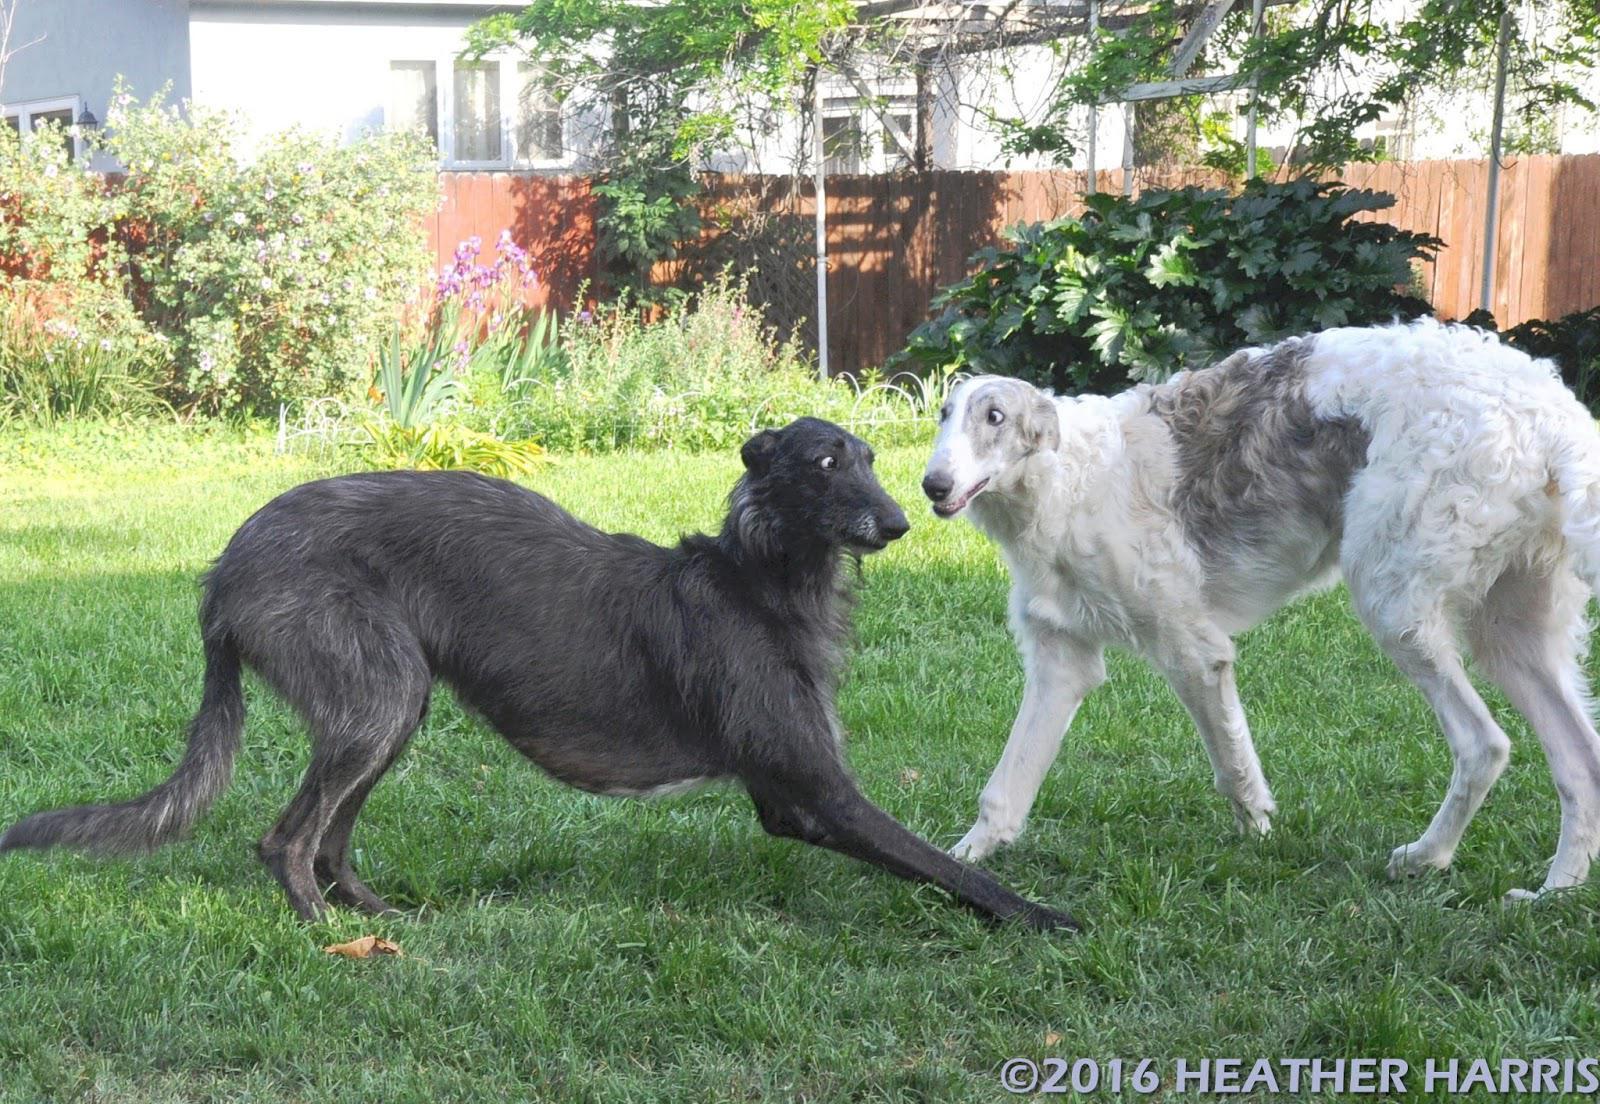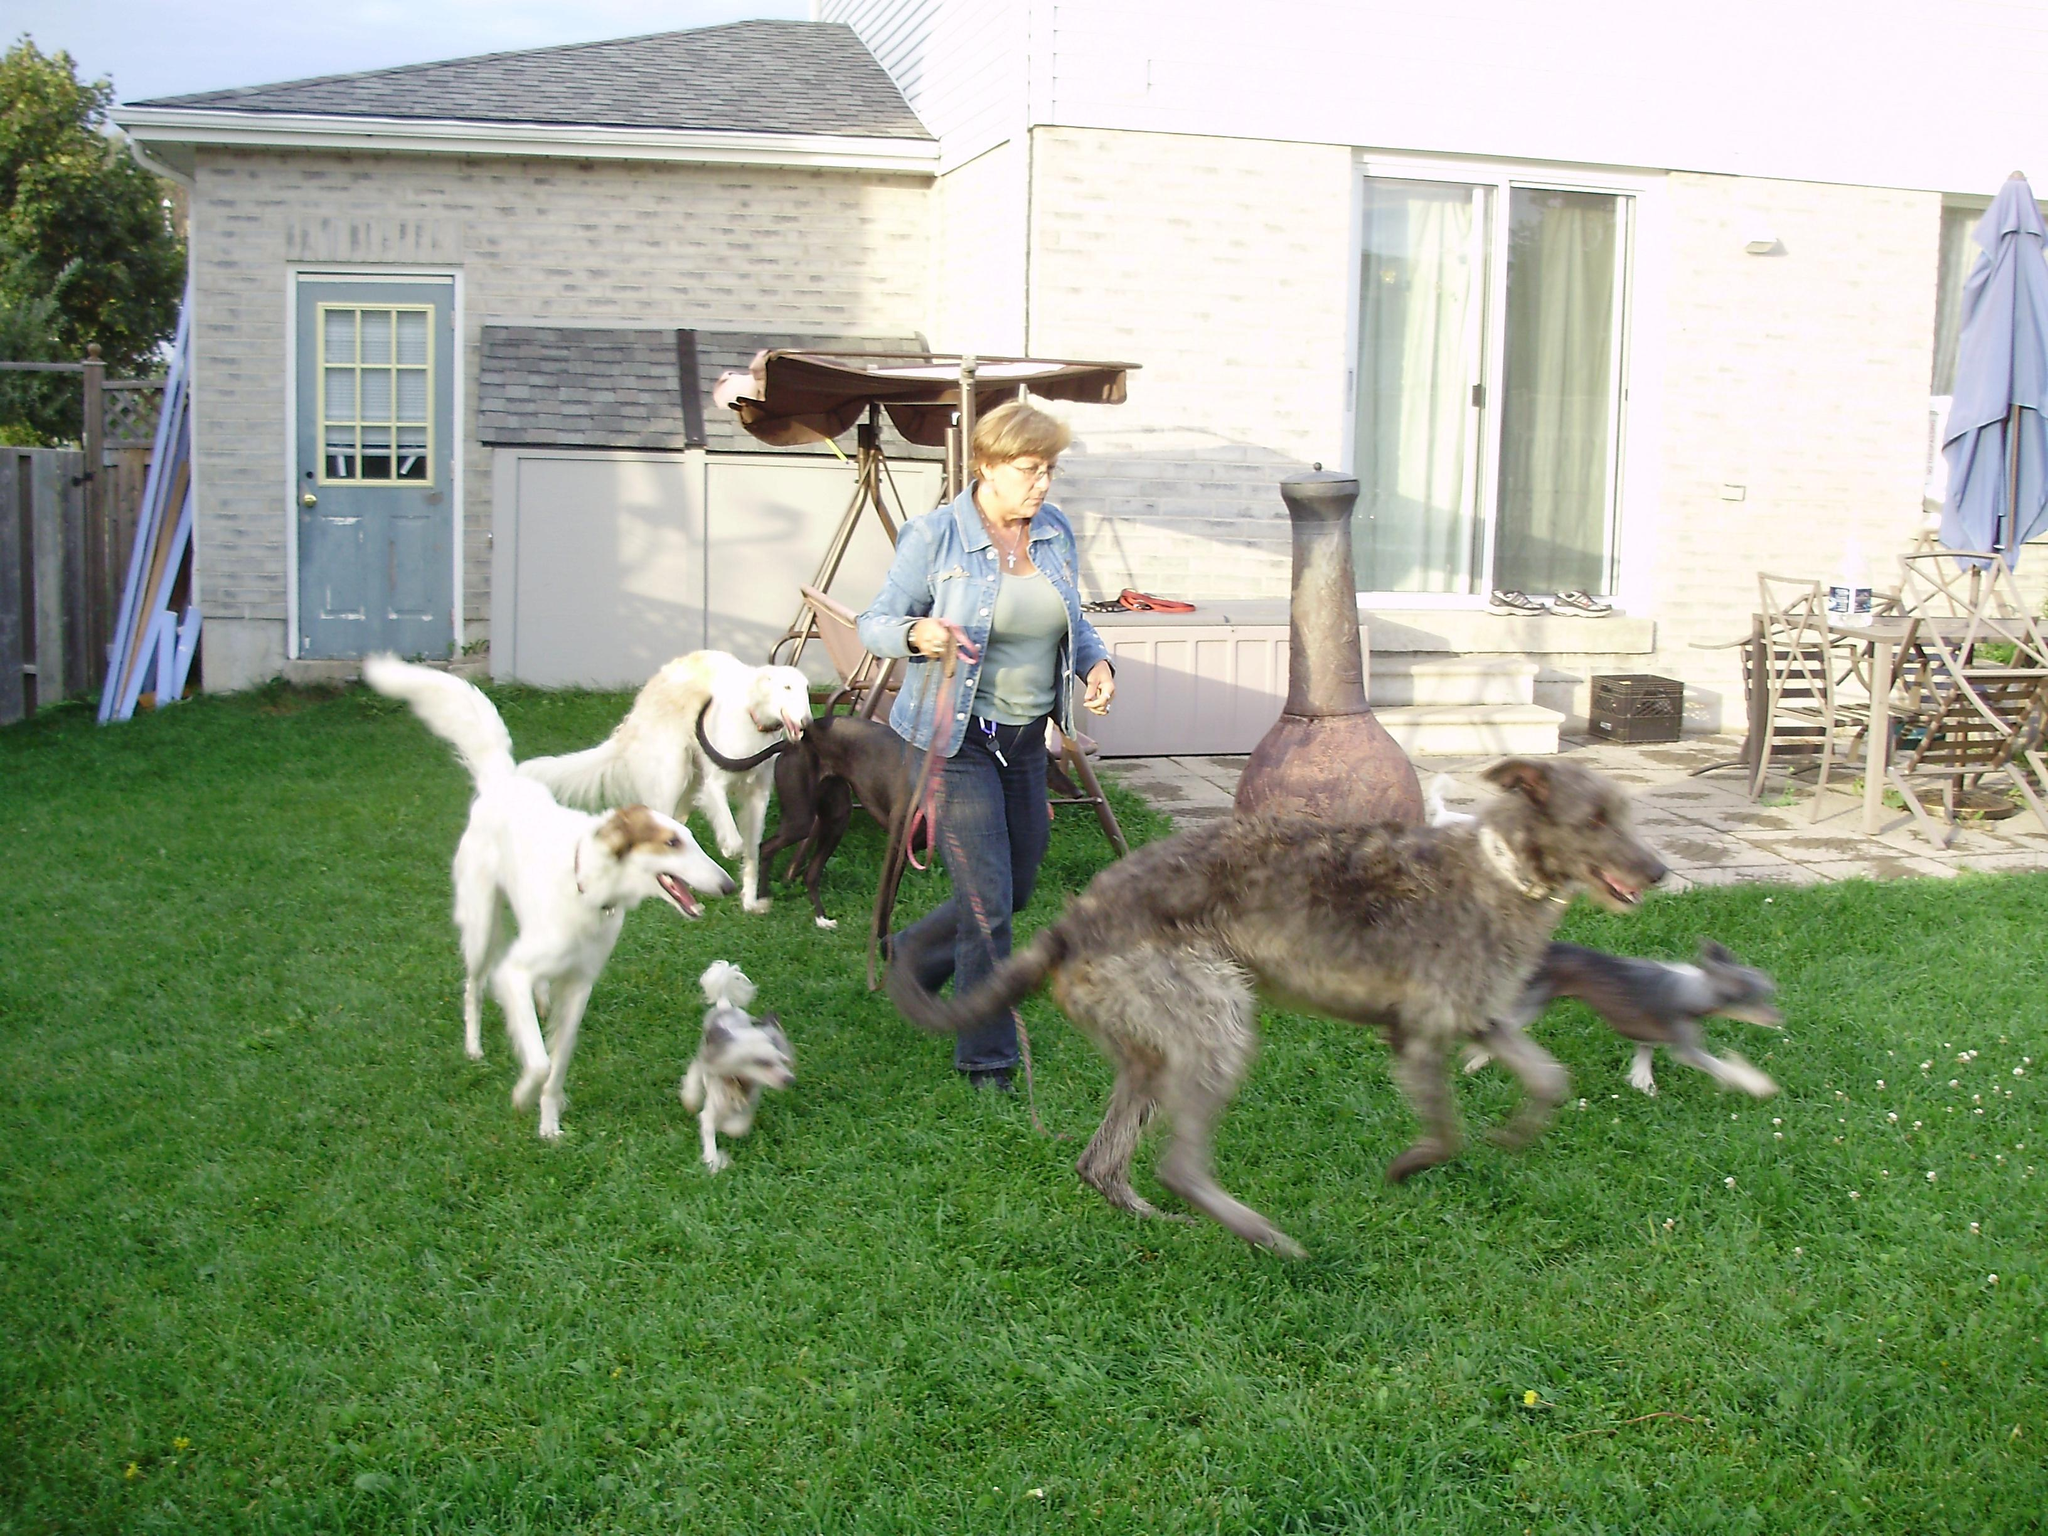The first image is the image on the left, the second image is the image on the right. Examine the images to the left and right. Is the description "The left image contains exactly two dogs." accurate? Answer yes or no. Yes. 